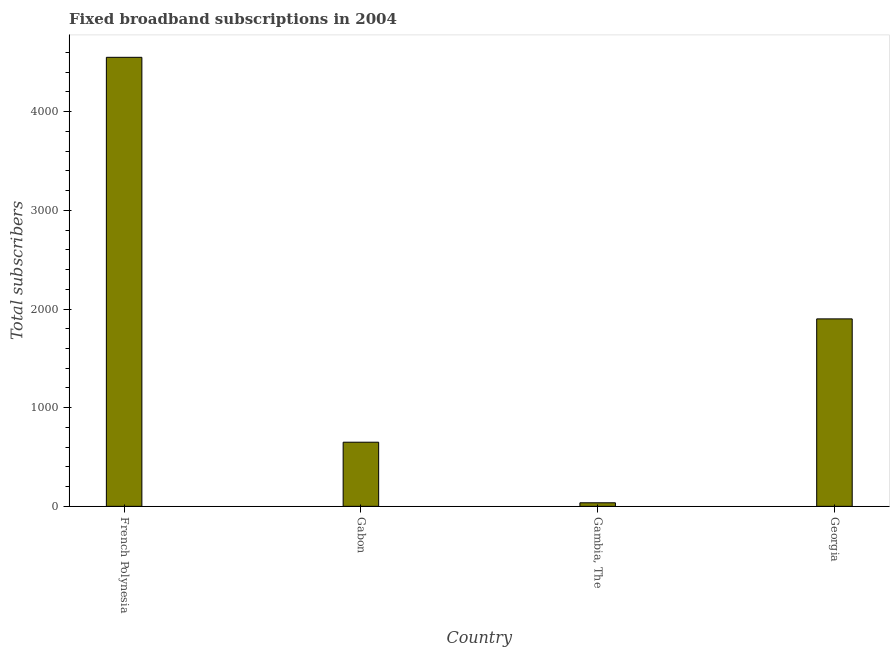What is the title of the graph?
Provide a short and direct response. Fixed broadband subscriptions in 2004. What is the label or title of the X-axis?
Your response must be concise. Country. What is the label or title of the Y-axis?
Your answer should be very brief. Total subscribers. What is the total number of fixed broadband subscriptions in Georgia?
Provide a short and direct response. 1900. Across all countries, what is the maximum total number of fixed broadband subscriptions?
Provide a short and direct response. 4551. Across all countries, what is the minimum total number of fixed broadband subscriptions?
Give a very brief answer. 36. In which country was the total number of fixed broadband subscriptions maximum?
Give a very brief answer. French Polynesia. In which country was the total number of fixed broadband subscriptions minimum?
Your answer should be very brief. Gambia, The. What is the sum of the total number of fixed broadband subscriptions?
Provide a succinct answer. 7137. What is the difference between the total number of fixed broadband subscriptions in Gabon and Georgia?
Provide a succinct answer. -1250. What is the average total number of fixed broadband subscriptions per country?
Give a very brief answer. 1784. What is the median total number of fixed broadband subscriptions?
Keep it short and to the point. 1275. What is the ratio of the total number of fixed broadband subscriptions in Gabon to that in Gambia, The?
Your answer should be compact. 18.06. Is the total number of fixed broadband subscriptions in French Polynesia less than that in Georgia?
Provide a succinct answer. No. Is the difference between the total number of fixed broadband subscriptions in French Polynesia and Gabon greater than the difference between any two countries?
Your answer should be very brief. No. What is the difference between the highest and the second highest total number of fixed broadband subscriptions?
Make the answer very short. 2651. What is the difference between the highest and the lowest total number of fixed broadband subscriptions?
Provide a short and direct response. 4515. In how many countries, is the total number of fixed broadband subscriptions greater than the average total number of fixed broadband subscriptions taken over all countries?
Keep it short and to the point. 2. How many bars are there?
Your answer should be very brief. 4. What is the difference between two consecutive major ticks on the Y-axis?
Provide a succinct answer. 1000. What is the Total subscribers in French Polynesia?
Offer a terse response. 4551. What is the Total subscribers of Gabon?
Your answer should be very brief. 650. What is the Total subscribers in Gambia, The?
Make the answer very short. 36. What is the Total subscribers in Georgia?
Provide a succinct answer. 1900. What is the difference between the Total subscribers in French Polynesia and Gabon?
Offer a very short reply. 3901. What is the difference between the Total subscribers in French Polynesia and Gambia, The?
Your answer should be very brief. 4515. What is the difference between the Total subscribers in French Polynesia and Georgia?
Provide a succinct answer. 2651. What is the difference between the Total subscribers in Gabon and Gambia, The?
Provide a succinct answer. 614. What is the difference between the Total subscribers in Gabon and Georgia?
Keep it short and to the point. -1250. What is the difference between the Total subscribers in Gambia, The and Georgia?
Provide a succinct answer. -1864. What is the ratio of the Total subscribers in French Polynesia to that in Gabon?
Give a very brief answer. 7. What is the ratio of the Total subscribers in French Polynesia to that in Gambia, The?
Provide a short and direct response. 126.42. What is the ratio of the Total subscribers in French Polynesia to that in Georgia?
Ensure brevity in your answer.  2.4. What is the ratio of the Total subscribers in Gabon to that in Gambia, The?
Ensure brevity in your answer.  18.06. What is the ratio of the Total subscribers in Gabon to that in Georgia?
Give a very brief answer. 0.34. What is the ratio of the Total subscribers in Gambia, The to that in Georgia?
Keep it short and to the point. 0.02. 